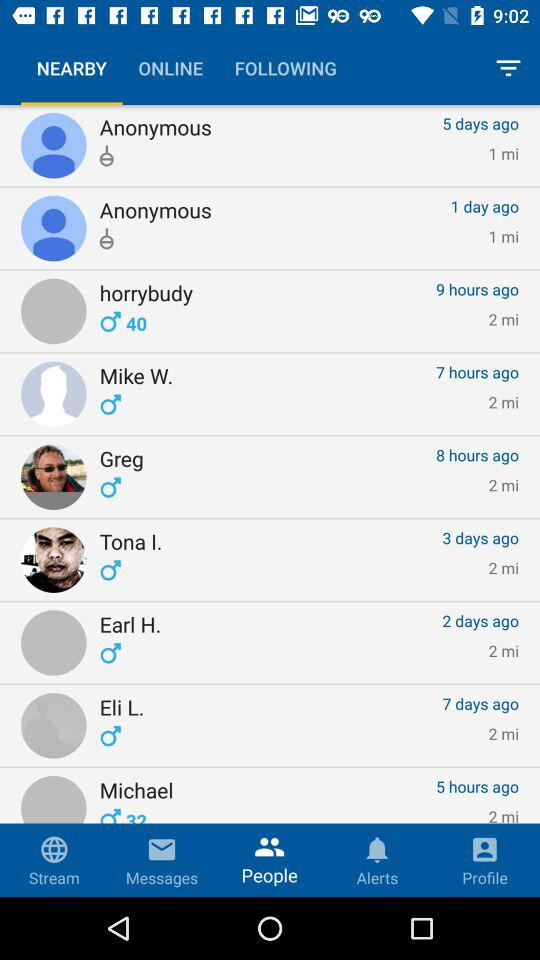What is the distance between Earl H. and my location? The distance between Earl H. and my location is 2 miles. 